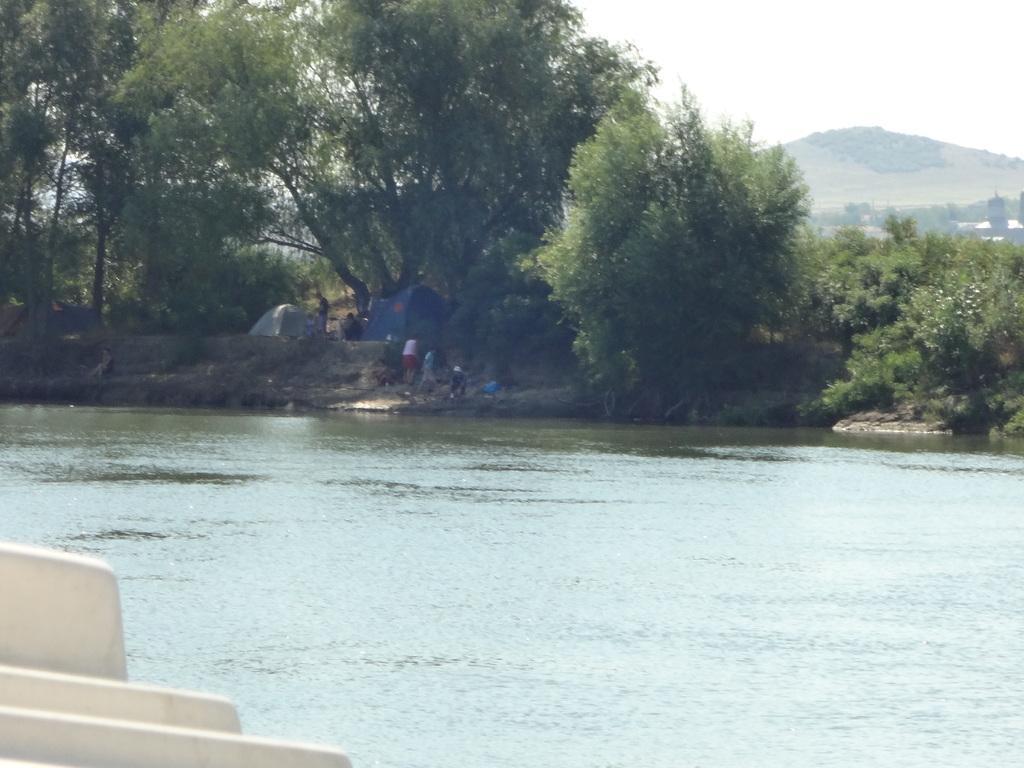Could you give a brief overview of what you see in this image? In the left bottom of the picture, we see wall in white color. In the middle of the picture, we see water and this water might be in the river. Beside that, we see people are standing. Beside them, we see tents in white and blue color. There are trees and hills in the background. 